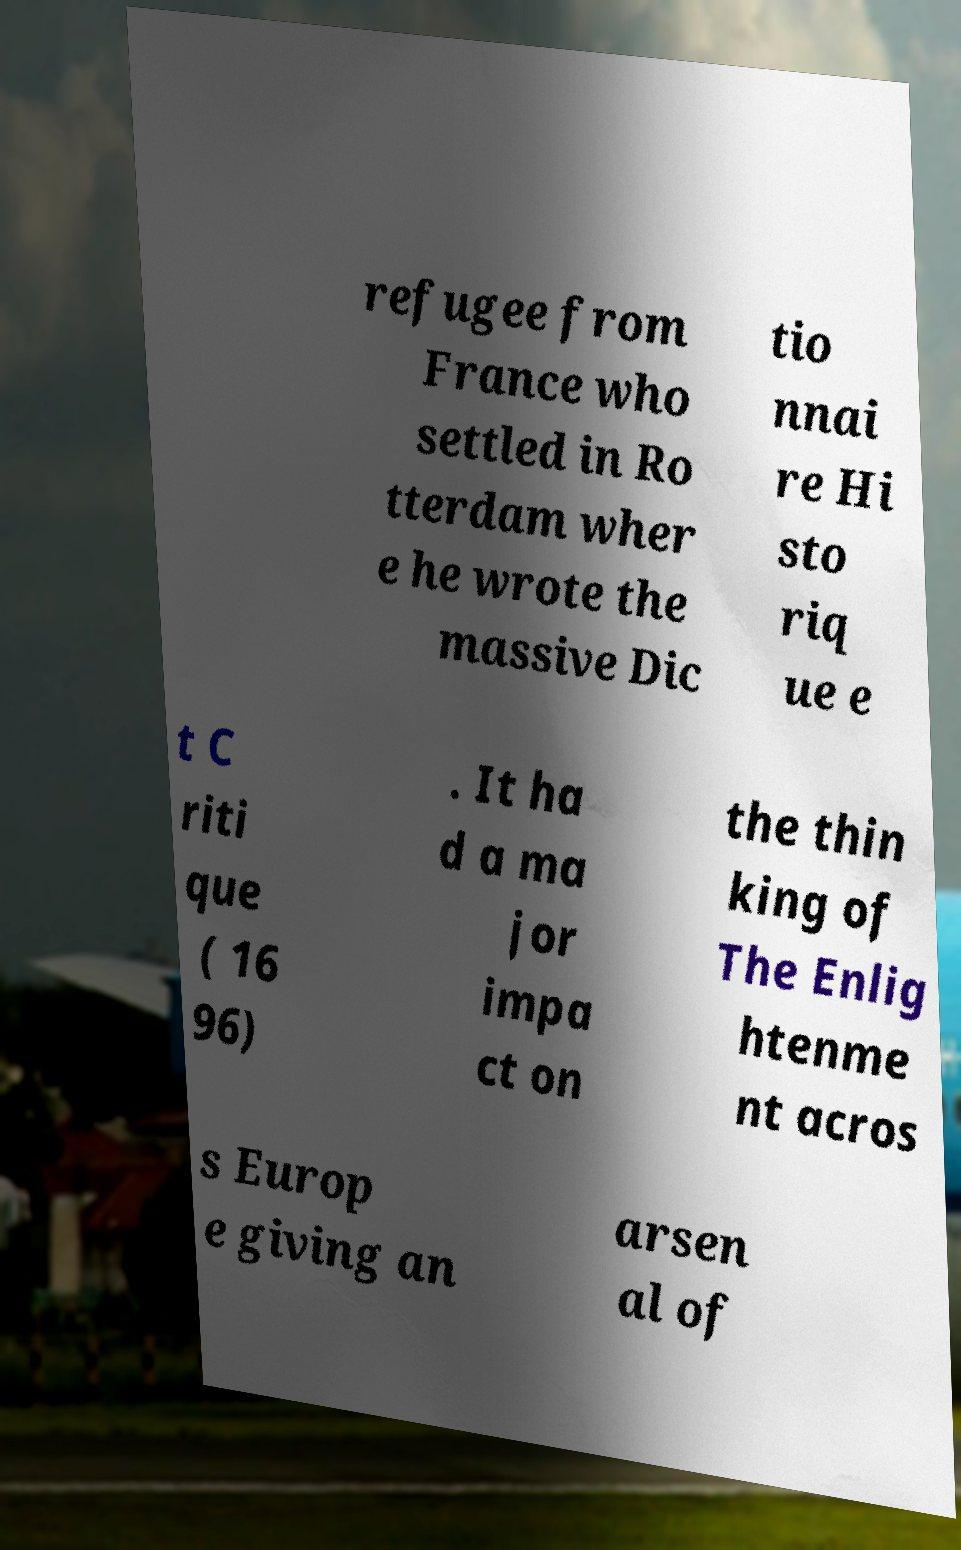Can you read and provide the text displayed in the image?This photo seems to have some interesting text. Can you extract and type it out for me? refugee from France who settled in Ro tterdam wher e he wrote the massive Dic tio nnai re Hi sto riq ue e t C riti que ( 16 96) . It ha d a ma jor impa ct on the thin king of The Enlig htenme nt acros s Europ e giving an arsen al of 